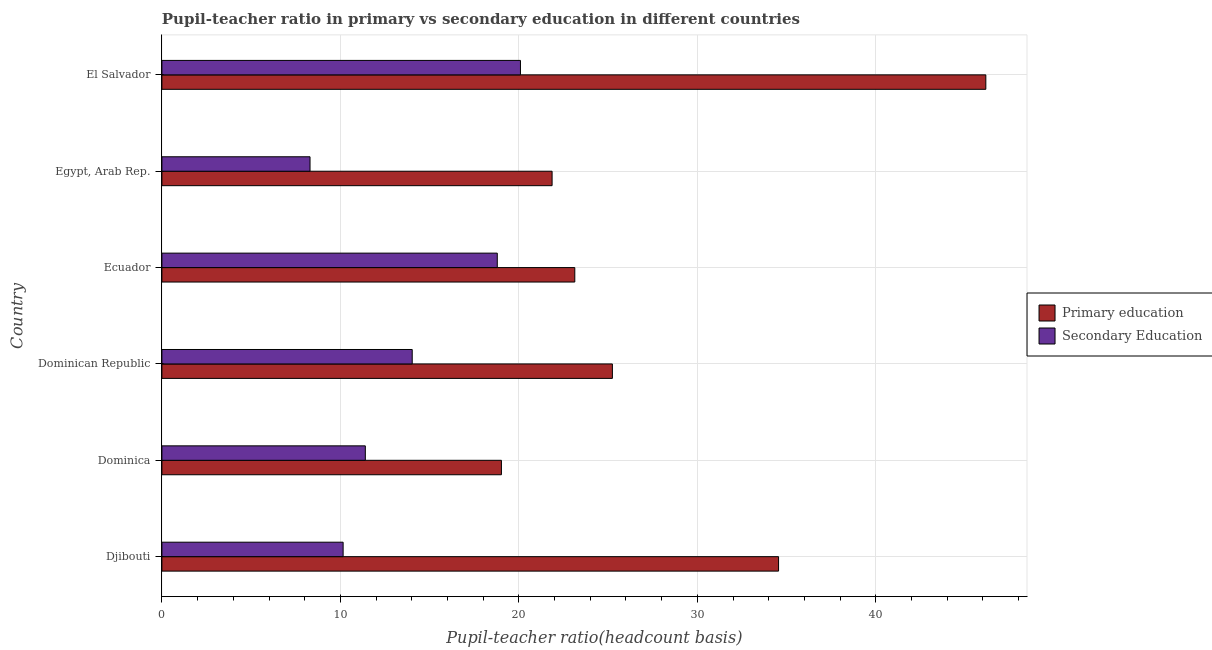How many different coloured bars are there?
Provide a short and direct response. 2. Are the number of bars per tick equal to the number of legend labels?
Your response must be concise. Yes. How many bars are there on the 1st tick from the top?
Provide a succinct answer. 2. What is the label of the 2nd group of bars from the top?
Offer a terse response. Egypt, Arab Rep. What is the pupil-teacher ratio in primary education in Ecuador?
Give a very brief answer. 23.13. Across all countries, what is the maximum pupil teacher ratio on secondary education?
Keep it short and to the point. 20.09. Across all countries, what is the minimum pupil-teacher ratio in primary education?
Give a very brief answer. 19.02. In which country was the pupil teacher ratio on secondary education maximum?
Your answer should be compact. El Salvador. In which country was the pupil-teacher ratio in primary education minimum?
Provide a short and direct response. Dominica. What is the total pupil-teacher ratio in primary education in the graph?
Provide a short and direct response. 169.96. What is the difference between the pupil-teacher ratio in primary education in Dominica and that in Dominican Republic?
Provide a succinct answer. -6.22. What is the difference between the pupil-teacher ratio in primary education in Djibouti and the pupil teacher ratio on secondary education in El Salvador?
Make the answer very short. 14.46. What is the average pupil teacher ratio on secondary education per country?
Provide a succinct answer. 13.79. What is the difference between the pupil teacher ratio on secondary education and pupil-teacher ratio in primary education in Djibouti?
Give a very brief answer. -24.39. In how many countries, is the pupil teacher ratio on secondary education greater than 46 ?
Offer a terse response. 0. What is the ratio of the pupil-teacher ratio in primary education in Dominica to that in El Salvador?
Ensure brevity in your answer.  0.41. What is the difference between the highest and the second highest pupil teacher ratio on secondary education?
Provide a succinct answer. 1.3. What is the difference between the highest and the lowest pupil teacher ratio on secondary education?
Provide a short and direct response. 11.79. In how many countries, is the pupil-teacher ratio in primary education greater than the average pupil-teacher ratio in primary education taken over all countries?
Offer a very short reply. 2. What does the 1st bar from the top in Djibouti represents?
Your answer should be very brief. Secondary Education. What does the 1st bar from the bottom in Dominican Republic represents?
Provide a short and direct response. Primary education. How many bars are there?
Your response must be concise. 12. Are all the bars in the graph horizontal?
Offer a very short reply. Yes. How many countries are there in the graph?
Your response must be concise. 6. Are the values on the major ticks of X-axis written in scientific E-notation?
Your answer should be compact. No. Where does the legend appear in the graph?
Your response must be concise. Center right. How many legend labels are there?
Your answer should be very brief. 2. What is the title of the graph?
Offer a terse response. Pupil-teacher ratio in primary vs secondary education in different countries. What is the label or title of the X-axis?
Offer a terse response. Pupil-teacher ratio(headcount basis). What is the label or title of the Y-axis?
Give a very brief answer. Country. What is the Pupil-teacher ratio(headcount basis) of Primary education in Djibouti?
Provide a succinct answer. 34.55. What is the Pupil-teacher ratio(headcount basis) in Secondary Education in Djibouti?
Keep it short and to the point. 10.15. What is the Pupil-teacher ratio(headcount basis) in Primary education in Dominica?
Provide a succinct answer. 19.02. What is the Pupil-teacher ratio(headcount basis) in Secondary Education in Dominica?
Your answer should be very brief. 11.4. What is the Pupil-teacher ratio(headcount basis) of Primary education in Dominican Republic?
Offer a terse response. 25.24. What is the Pupil-teacher ratio(headcount basis) of Secondary Education in Dominican Republic?
Provide a short and direct response. 14.02. What is the Pupil-teacher ratio(headcount basis) of Primary education in Ecuador?
Make the answer very short. 23.13. What is the Pupil-teacher ratio(headcount basis) in Secondary Education in Ecuador?
Give a very brief answer. 18.79. What is the Pupil-teacher ratio(headcount basis) in Primary education in Egypt, Arab Rep.?
Your response must be concise. 21.86. What is the Pupil-teacher ratio(headcount basis) in Secondary Education in Egypt, Arab Rep.?
Your response must be concise. 8.3. What is the Pupil-teacher ratio(headcount basis) of Primary education in El Salvador?
Make the answer very short. 46.16. What is the Pupil-teacher ratio(headcount basis) in Secondary Education in El Salvador?
Keep it short and to the point. 20.09. Across all countries, what is the maximum Pupil-teacher ratio(headcount basis) of Primary education?
Your answer should be very brief. 46.16. Across all countries, what is the maximum Pupil-teacher ratio(headcount basis) of Secondary Education?
Your answer should be very brief. 20.09. Across all countries, what is the minimum Pupil-teacher ratio(headcount basis) of Primary education?
Ensure brevity in your answer.  19.02. Across all countries, what is the minimum Pupil-teacher ratio(headcount basis) of Secondary Education?
Keep it short and to the point. 8.3. What is the total Pupil-teacher ratio(headcount basis) in Primary education in the graph?
Offer a very short reply. 169.96. What is the total Pupil-teacher ratio(headcount basis) in Secondary Education in the graph?
Offer a very short reply. 82.75. What is the difference between the Pupil-teacher ratio(headcount basis) in Primary education in Djibouti and that in Dominica?
Give a very brief answer. 15.53. What is the difference between the Pupil-teacher ratio(headcount basis) in Secondary Education in Djibouti and that in Dominica?
Make the answer very short. -1.24. What is the difference between the Pupil-teacher ratio(headcount basis) of Primary education in Djibouti and that in Dominican Republic?
Provide a short and direct response. 9.31. What is the difference between the Pupil-teacher ratio(headcount basis) in Secondary Education in Djibouti and that in Dominican Republic?
Keep it short and to the point. -3.87. What is the difference between the Pupil-teacher ratio(headcount basis) of Primary education in Djibouti and that in Ecuador?
Ensure brevity in your answer.  11.42. What is the difference between the Pupil-teacher ratio(headcount basis) of Secondary Education in Djibouti and that in Ecuador?
Offer a terse response. -8.64. What is the difference between the Pupil-teacher ratio(headcount basis) in Primary education in Djibouti and that in Egypt, Arab Rep.?
Keep it short and to the point. 12.69. What is the difference between the Pupil-teacher ratio(headcount basis) of Secondary Education in Djibouti and that in Egypt, Arab Rep.?
Offer a very short reply. 1.85. What is the difference between the Pupil-teacher ratio(headcount basis) in Primary education in Djibouti and that in El Salvador?
Make the answer very short. -11.61. What is the difference between the Pupil-teacher ratio(headcount basis) of Secondary Education in Djibouti and that in El Salvador?
Your answer should be compact. -9.93. What is the difference between the Pupil-teacher ratio(headcount basis) in Primary education in Dominica and that in Dominican Republic?
Keep it short and to the point. -6.22. What is the difference between the Pupil-teacher ratio(headcount basis) of Secondary Education in Dominica and that in Dominican Republic?
Offer a very short reply. -2.63. What is the difference between the Pupil-teacher ratio(headcount basis) in Primary education in Dominica and that in Ecuador?
Your answer should be very brief. -4.11. What is the difference between the Pupil-teacher ratio(headcount basis) in Secondary Education in Dominica and that in Ecuador?
Your answer should be compact. -7.39. What is the difference between the Pupil-teacher ratio(headcount basis) of Primary education in Dominica and that in Egypt, Arab Rep.?
Your response must be concise. -2.84. What is the difference between the Pupil-teacher ratio(headcount basis) in Secondary Education in Dominica and that in Egypt, Arab Rep.?
Offer a very short reply. 3.1. What is the difference between the Pupil-teacher ratio(headcount basis) in Primary education in Dominica and that in El Salvador?
Your answer should be compact. -27.14. What is the difference between the Pupil-teacher ratio(headcount basis) in Secondary Education in Dominica and that in El Salvador?
Keep it short and to the point. -8.69. What is the difference between the Pupil-teacher ratio(headcount basis) in Primary education in Dominican Republic and that in Ecuador?
Give a very brief answer. 2.11. What is the difference between the Pupil-teacher ratio(headcount basis) of Secondary Education in Dominican Republic and that in Ecuador?
Give a very brief answer. -4.77. What is the difference between the Pupil-teacher ratio(headcount basis) of Primary education in Dominican Republic and that in Egypt, Arab Rep.?
Your answer should be compact. 3.38. What is the difference between the Pupil-teacher ratio(headcount basis) in Secondary Education in Dominican Republic and that in Egypt, Arab Rep.?
Ensure brevity in your answer.  5.73. What is the difference between the Pupil-teacher ratio(headcount basis) of Primary education in Dominican Republic and that in El Salvador?
Give a very brief answer. -20.92. What is the difference between the Pupil-teacher ratio(headcount basis) of Secondary Education in Dominican Republic and that in El Salvador?
Provide a short and direct response. -6.06. What is the difference between the Pupil-teacher ratio(headcount basis) in Primary education in Ecuador and that in Egypt, Arab Rep.?
Ensure brevity in your answer.  1.27. What is the difference between the Pupil-teacher ratio(headcount basis) in Secondary Education in Ecuador and that in Egypt, Arab Rep.?
Provide a short and direct response. 10.49. What is the difference between the Pupil-teacher ratio(headcount basis) in Primary education in Ecuador and that in El Salvador?
Your response must be concise. -23.03. What is the difference between the Pupil-teacher ratio(headcount basis) of Secondary Education in Ecuador and that in El Salvador?
Your answer should be very brief. -1.3. What is the difference between the Pupil-teacher ratio(headcount basis) of Primary education in Egypt, Arab Rep. and that in El Salvador?
Provide a succinct answer. -24.3. What is the difference between the Pupil-teacher ratio(headcount basis) in Secondary Education in Egypt, Arab Rep. and that in El Salvador?
Ensure brevity in your answer.  -11.79. What is the difference between the Pupil-teacher ratio(headcount basis) of Primary education in Djibouti and the Pupil-teacher ratio(headcount basis) of Secondary Education in Dominica?
Keep it short and to the point. 23.15. What is the difference between the Pupil-teacher ratio(headcount basis) in Primary education in Djibouti and the Pupil-teacher ratio(headcount basis) in Secondary Education in Dominican Republic?
Your response must be concise. 20.52. What is the difference between the Pupil-teacher ratio(headcount basis) in Primary education in Djibouti and the Pupil-teacher ratio(headcount basis) in Secondary Education in Ecuador?
Ensure brevity in your answer.  15.76. What is the difference between the Pupil-teacher ratio(headcount basis) of Primary education in Djibouti and the Pupil-teacher ratio(headcount basis) of Secondary Education in Egypt, Arab Rep.?
Your response must be concise. 26.25. What is the difference between the Pupil-teacher ratio(headcount basis) in Primary education in Djibouti and the Pupil-teacher ratio(headcount basis) in Secondary Education in El Salvador?
Offer a terse response. 14.46. What is the difference between the Pupil-teacher ratio(headcount basis) of Primary education in Dominica and the Pupil-teacher ratio(headcount basis) of Secondary Education in Dominican Republic?
Provide a short and direct response. 5. What is the difference between the Pupil-teacher ratio(headcount basis) in Primary education in Dominica and the Pupil-teacher ratio(headcount basis) in Secondary Education in Ecuador?
Give a very brief answer. 0.23. What is the difference between the Pupil-teacher ratio(headcount basis) in Primary education in Dominica and the Pupil-teacher ratio(headcount basis) in Secondary Education in Egypt, Arab Rep.?
Ensure brevity in your answer.  10.72. What is the difference between the Pupil-teacher ratio(headcount basis) in Primary education in Dominica and the Pupil-teacher ratio(headcount basis) in Secondary Education in El Salvador?
Make the answer very short. -1.07. What is the difference between the Pupil-teacher ratio(headcount basis) in Primary education in Dominican Republic and the Pupil-teacher ratio(headcount basis) in Secondary Education in Ecuador?
Provide a short and direct response. 6.45. What is the difference between the Pupil-teacher ratio(headcount basis) in Primary education in Dominican Republic and the Pupil-teacher ratio(headcount basis) in Secondary Education in Egypt, Arab Rep.?
Provide a succinct answer. 16.94. What is the difference between the Pupil-teacher ratio(headcount basis) of Primary education in Dominican Republic and the Pupil-teacher ratio(headcount basis) of Secondary Education in El Salvador?
Offer a terse response. 5.15. What is the difference between the Pupil-teacher ratio(headcount basis) in Primary education in Ecuador and the Pupil-teacher ratio(headcount basis) in Secondary Education in Egypt, Arab Rep.?
Your response must be concise. 14.83. What is the difference between the Pupil-teacher ratio(headcount basis) in Primary education in Ecuador and the Pupil-teacher ratio(headcount basis) in Secondary Education in El Salvador?
Make the answer very short. 3.04. What is the difference between the Pupil-teacher ratio(headcount basis) in Primary education in Egypt, Arab Rep. and the Pupil-teacher ratio(headcount basis) in Secondary Education in El Salvador?
Your answer should be very brief. 1.77. What is the average Pupil-teacher ratio(headcount basis) of Primary education per country?
Make the answer very short. 28.33. What is the average Pupil-teacher ratio(headcount basis) of Secondary Education per country?
Give a very brief answer. 13.79. What is the difference between the Pupil-teacher ratio(headcount basis) of Primary education and Pupil-teacher ratio(headcount basis) of Secondary Education in Djibouti?
Your response must be concise. 24.39. What is the difference between the Pupil-teacher ratio(headcount basis) in Primary education and Pupil-teacher ratio(headcount basis) in Secondary Education in Dominica?
Provide a succinct answer. 7.62. What is the difference between the Pupil-teacher ratio(headcount basis) in Primary education and Pupil-teacher ratio(headcount basis) in Secondary Education in Dominican Republic?
Provide a short and direct response. 11.21. What is the difference between the Pupil-teacher ratio(headcount basis) of Primary education and Pupil-teacher ratio(headcount basis) of Secondary Education in Ecuador?
Offer a terse response. 4.34. What is the difference between the Pupil-teacher ratio(headcount basis) in Primary education and Pupil-teacher ratio(headcount basis) in Secondary Education in Egypt, Arab Rep.?
Your response must be concise. 13.56. What is the difference between the Pupil-teacher ratio(headcount basis) of Primary education and Pupil-teacher ratio(headcount basis) of Secondary Education in El Salvador?
Your answer should be very brief. 26.07. What is the ratio of the Pupil-teacher ratio(headcount basis) of Primary education in Djibouti to that in Dominica?
Offer a terse response. 1.82. What is the ratio of the Pupil-teacher ratio(headcount basis) in Secondary Education in Djibouti to that in Dominica?
Provide a short and direct response. 0.89. What is the ratio of the Pupil-teacher ratio(headcount basis) of Primary education in Djibouti to that in Dominican Republic?
Provide a succinct answer. 1.37. What is the ratio of the Pupil-teacher ratio(headcount basis) of Secondary Education in Djibouti to that in Dominican Republic?
Make the answer very short. 0.72. What is the ratio of the Pupil-teacher ratio(headcount basis) in Primary education in Djibouti to that in Ecuador?
Keep it short and to the point. 1.49. What is the ratio of the Pupil-teacher ratio(headcount basis) of Secondary Education in Djibouti to that in Ecuador?
Your response must be concise. 0.54. What is the ratio of the Pupil-teacher ratio(headcount basis) in Primary education in Djibouti to that in Egypt, Arab Rep.?
Make the answer very short. 1.58. What is the ratio of the Pupil-teacher ratio(headcount basis) of Secondary Education in Djibouti to that in Egypt, Arab Rep.?
Your response must be concise. 1.22. What is the ratio of the Pupil-teacher ratio(headcount basis) in Primary education in Djibouti to that in El Salvador?
Give a very brief answer. 0.75. What is the ratio of the Pupil-teacher ratio(headcount basis) in Secondary Education in Djibouti to that in El Salvador?
Keep it short and to the point. 0.51. What is the ratio of the Pupil-teacher ratio(headcount basis) in Primary education in Dominica to that in Dominican Republic?
Make the answer very short. 0.75. What is the ratio of the Pupil-teacher ratio(headcount basis) of Secondary Education in Dominica to that in Dominican Republic?
Your answer should be very brief. 0.81. What is the ratio of the Pupil-teacher ratio(headcount basis) of Primary education in Dominica to that in Ecuador?
Your answer should be compact. 0.82. What is the ratio of the Pupil-teacher ratio(headcount basis) of Secondary Education in Dominica to that in Ecuador?
Ensure brevity in your answer.  0.61. What is the ratio of the Pupil-teacher ratio(headcount basis) in Primary education in Dominica to that in Egypt, Arab Rep.?
Offer a terse response. 0.87. What is the ratio of the Pupil-teacher ratio(headcount basis) in Secondary Education in Dominica to that in Egypt, Arab Rep.?
Make the answer very short. 1.37. What is the ratio of the Pupil-teacher ratio(headcount basis) in Primary education in Dominica to that in El Salvador?
Your response must be concise. 0.41. What is the ratio of the Pupil-teacher ratio(headcount basis) of Secondary Education in Dominica to that in El Salvador?
Make the answer very short. 0.57. What is the ratio of the Pupil-teacher ratio(headcount basis) in Primary education in Dominican Republic to that in Ecuador?
Your answer should be very brief. 1.09. What is the ratio of the Pupil-teacher ratio(headcount basis) of Secondary Education in Dominican Republic to that in Ecuador?
Give a very brief answer. 0.75. What is the ratio of the Pupil-teacher ratio(headcount basis) of Primary education in Dominican Republic to that in Egypt, Arab Rep.?
Provide a succinct answer. 1.15. What is the ratio of the Pupil-teacher ratio(headcount basis) in Secondary Education in Dominican Republic to that in Egypt, Arab Rep.?
Offer a very short reply. 1.69. What is the ratio of the Pupil-teacher ratio(headcount basis) of Primary education in Dominican Republic to that in El Salvador?
Your answer should be compact. 0.55. What is the ratio of the Pupil-teacher ratio(headcount basis) in Secondary Education in Dominican Republic to that in El Salvador?
Keep it short and to the point. 0.7. What is the ratio of the Pupil-teacher ratio(headcount basis) in Primary education in Ecuador to that in Egypt, Arab Rep.?
Ensure brevity in your answer.  1.06. What is the ratio of the Pupil-teacher ratio(headcount basis) of Secondary Education in Ecuador to that in Egypt, Arab Rep.?
Offer a very short reply. 2.26. What is the ratio of the Pupil-teacher ratio(headcount basis) in Primary education in Ecuador to that in El Salvador?
Provide a succinct answer. 0.5. What is the ratio of the Pupil-teacher ratio(headcount basis) in Secondary Education in Ecuador to that in El Salvador?
Give a very brief answer. 0.94. What is the ratio of the Pupil-teacher ratio(headcount basis) in Primary education in Egypt, Arab Rep. to that in El Salvador?
Your answer should be compact. 0.47. What is the ratio of the Pupil-teacher ratio(headcount basis) of Secondary Education in Egypt, Arab Rep. to that in El Salvador?
Your answer should be compact. 0.41. What is the difference between the highest and the second highest Pupil-teacher ratio(headcount basis) in Primary education?
Keep it short and to the point. 11.61. What is the difference between the highest and the second highest Pupil-teacher ratio(headcount basis) in Secondary Education?
Your response must be concise. 1.3. What is the difference between the highest and the lowest Pupil-teacher ratio(headcount basis) in Primary education?
Offer a terse response. 27.14. What is the difference between the highest and the lowest Pupil-teacher ratio(headcount basis) in Secondary Education?
Your answer should be compact. 11.79. 